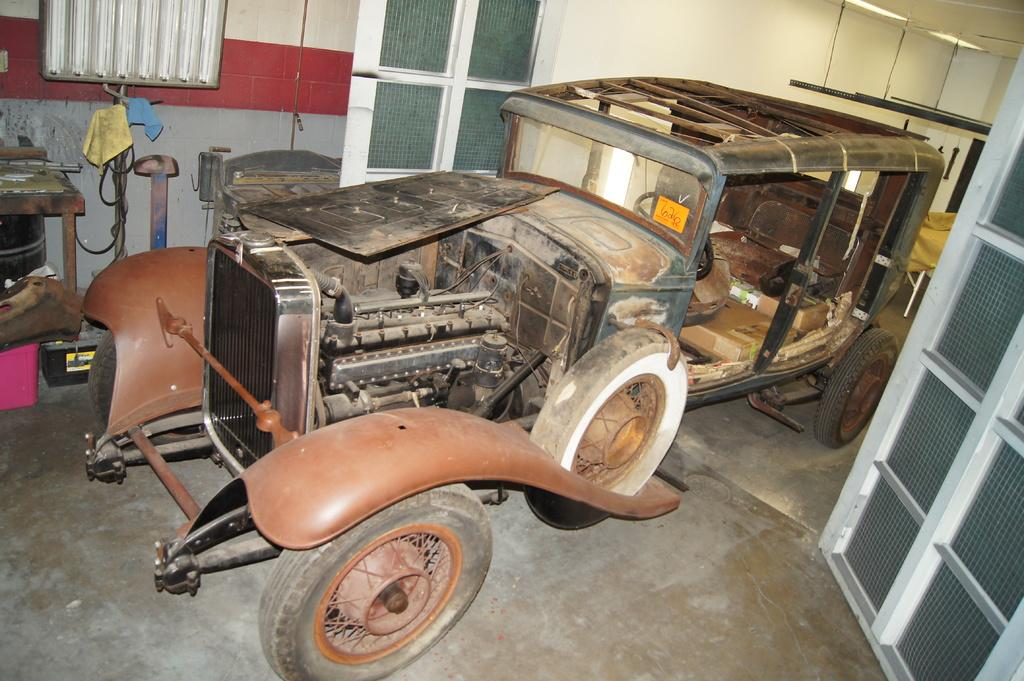What is the main subject in the center of the image? There is a vehicle in the center of the image. What can be seen in the background of the image? There is a wall, windows, a wire, clothes, and some objects in the background of the image. Can you describe the window on the right side of the image? There appears to be a window on the right side of the image. What type of trousers are hanging on the wire in the image? There is no wire with trousers hanging on it in the image. How does the brain interact with the vehicle in the image? There is no brain present in the image, so it cannot interact with the vehicle. 